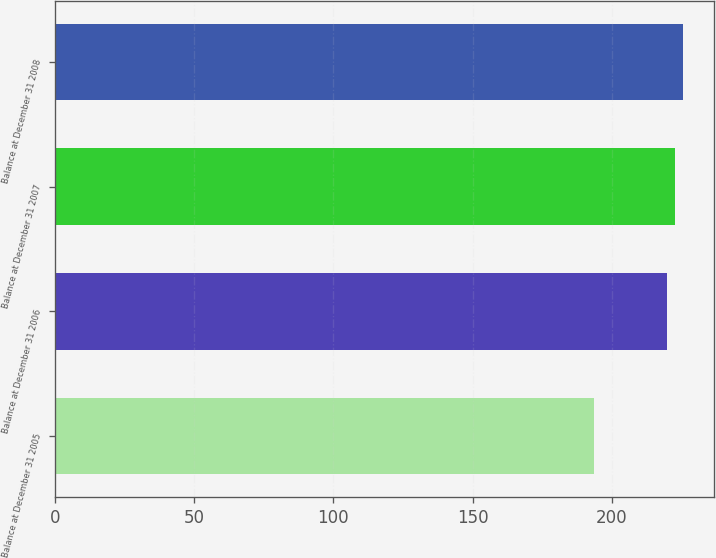<chart> <loc_0><loc_0><loc_500><loc_500><bar_chart><fcel>Balance at December 31 2005<fcel>Balance at December 31 2006<fcel>Balance at December 31 2007<fcel>Balance at December 31 2008<nl><fcel>193.8<fcel>220<fcel>222.79<fcel>225.58<nl></chart> 